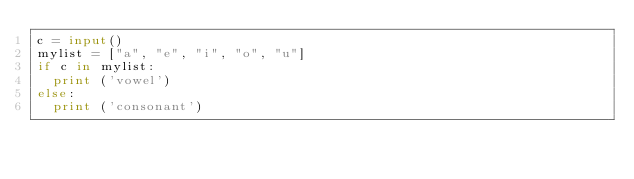<code> <loc_0><loc_0><loc_500><loc_500><_Python_>c = input()
mylist = ["a", "e", "i", "o", "u"]
if c in mylist:
  print ('vowel')
else:
  print ('consonant')</code> 